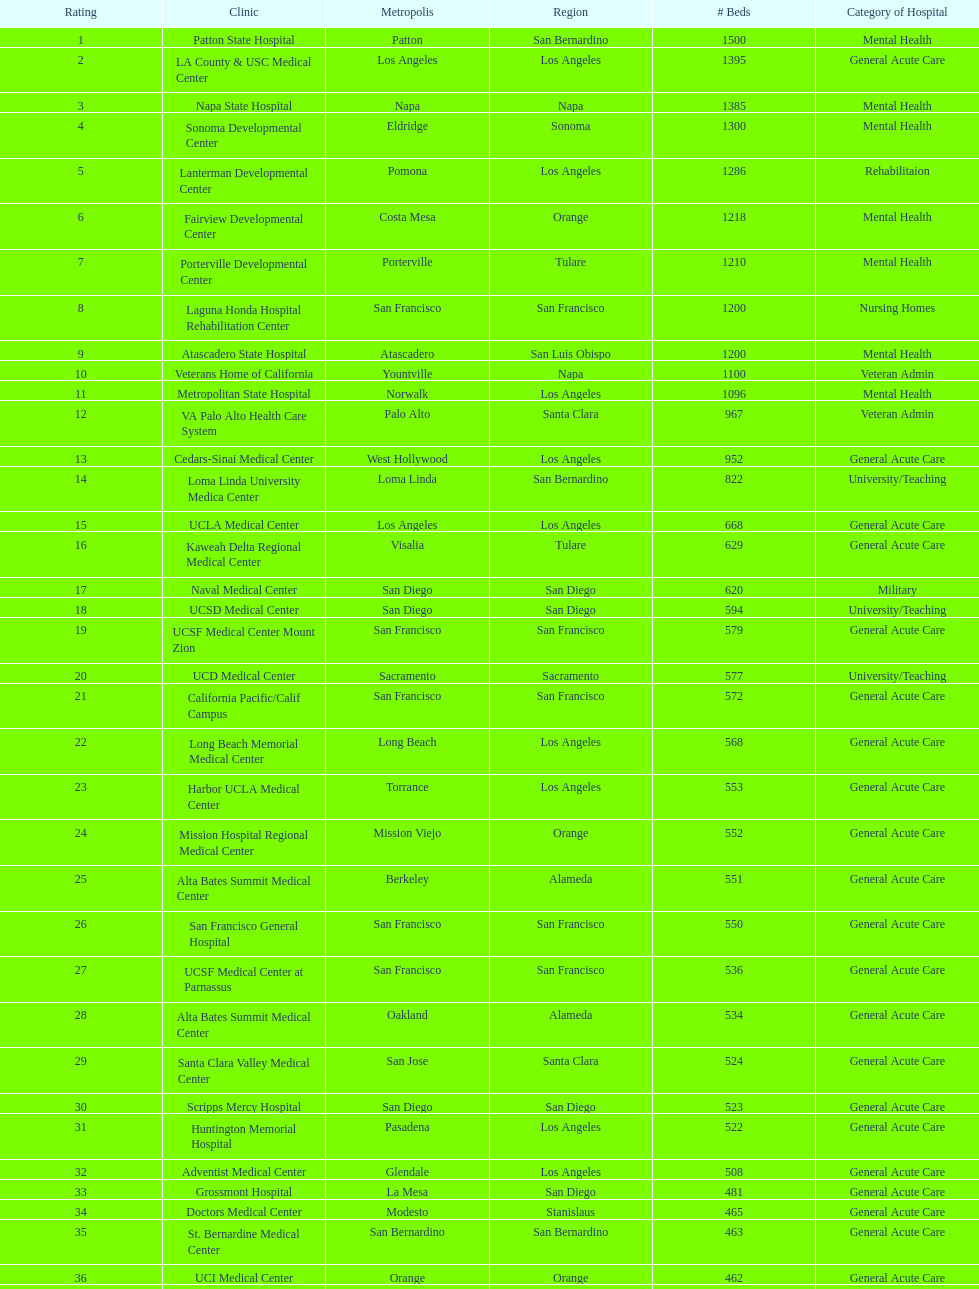What hospital in los angeles county providing hospital beds specifically for rehabilitation is ranked at least among the top 10 hospitals? Lanterman Developmental Center. 